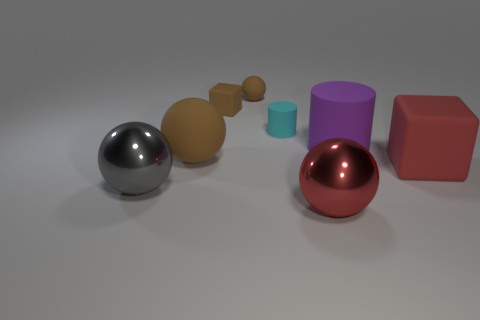Add 1 brown spheres. How many objects exist? 9 Subtract all blocks. How many objects are left? 6 Subtract all small matte spheres. Subtract all spheres. How many objects are left? 3 Add 1 big cubes. How many big cubes are left? 2 Add 6 large red objects. How many large red objects exist? 8 Subtract 0 yellow cubes. How many objects are left? 8 